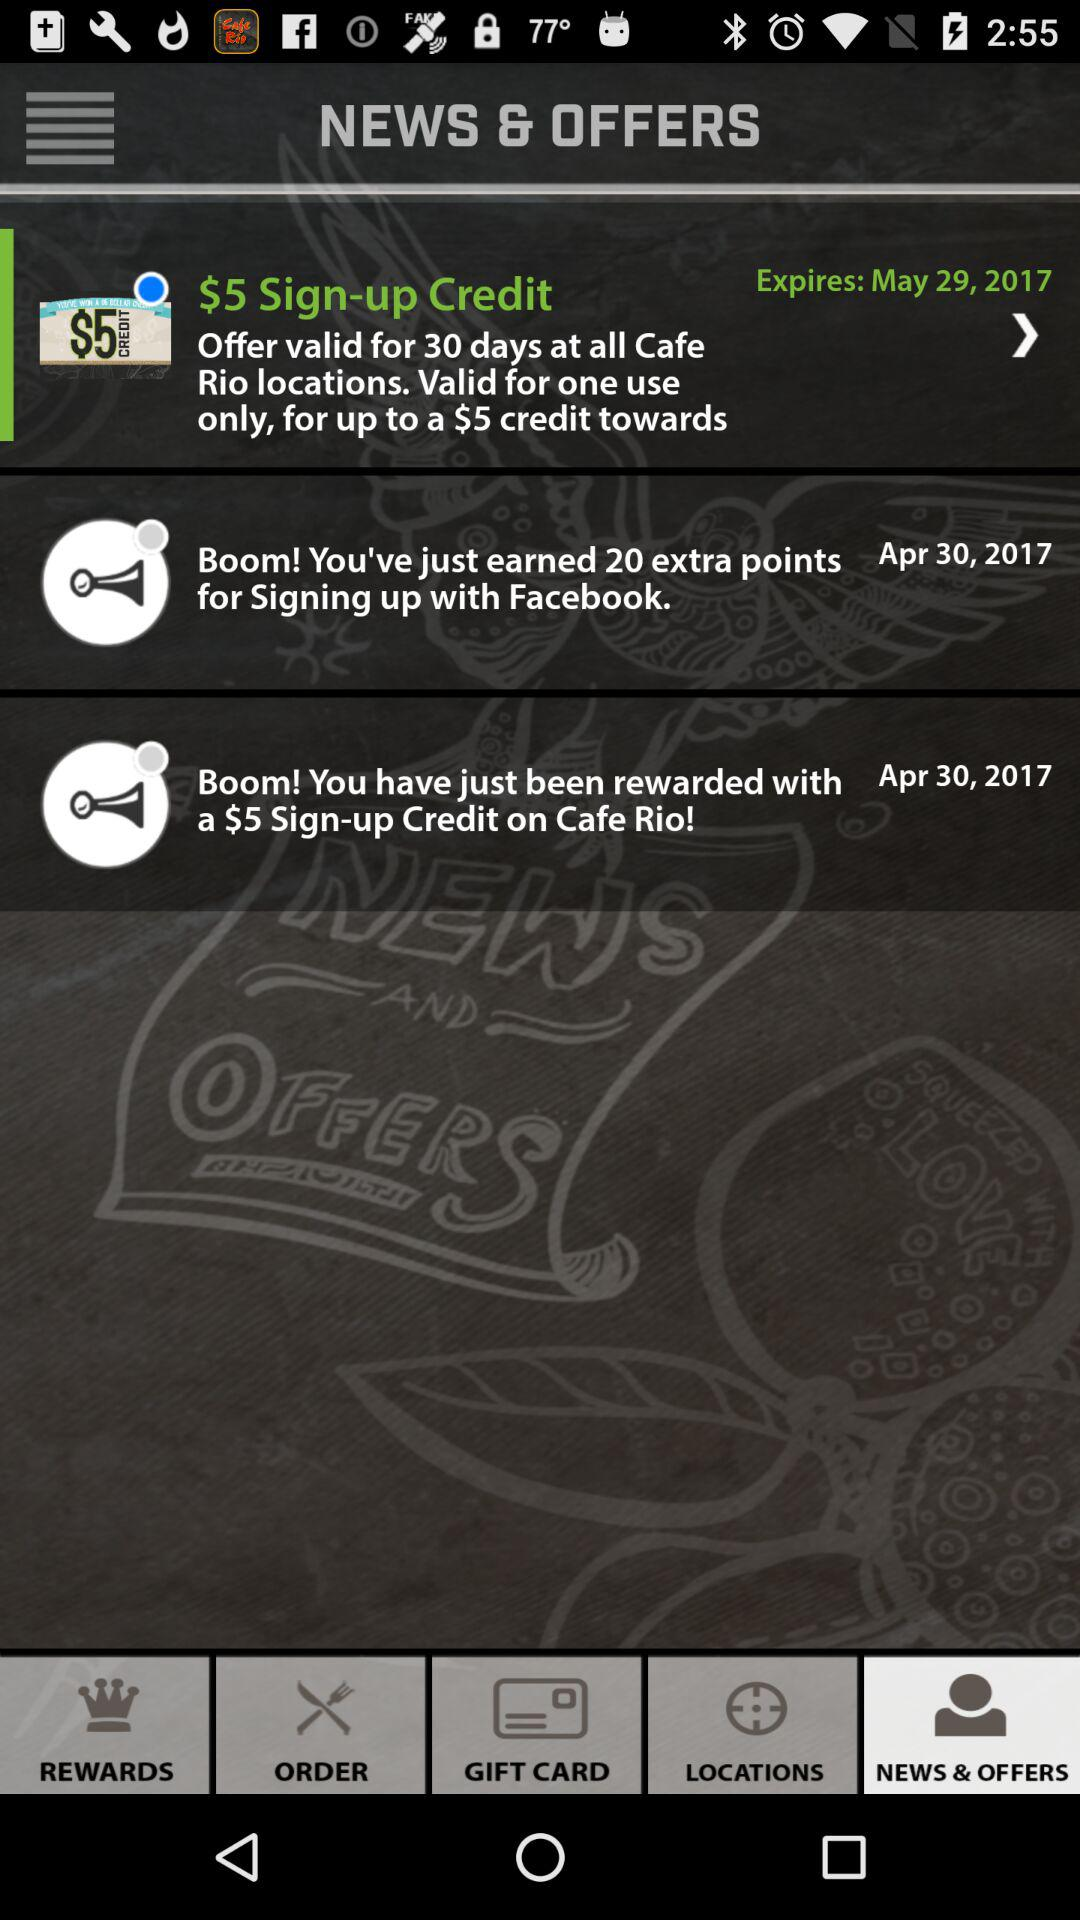How many points are being earned by signing up with Facebook? You have earned 20 extra points by signing up with Facebook. 